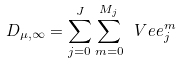<formula> <loc_0><loc_0><loc_500><loc_500>D _ { \mu , \infty } = \sum _ { j = 0 } ^ { J } \sum _ { m = 0 } ^ { M _ { j } } \ V e e ^ { m } _ { j }</formula> 